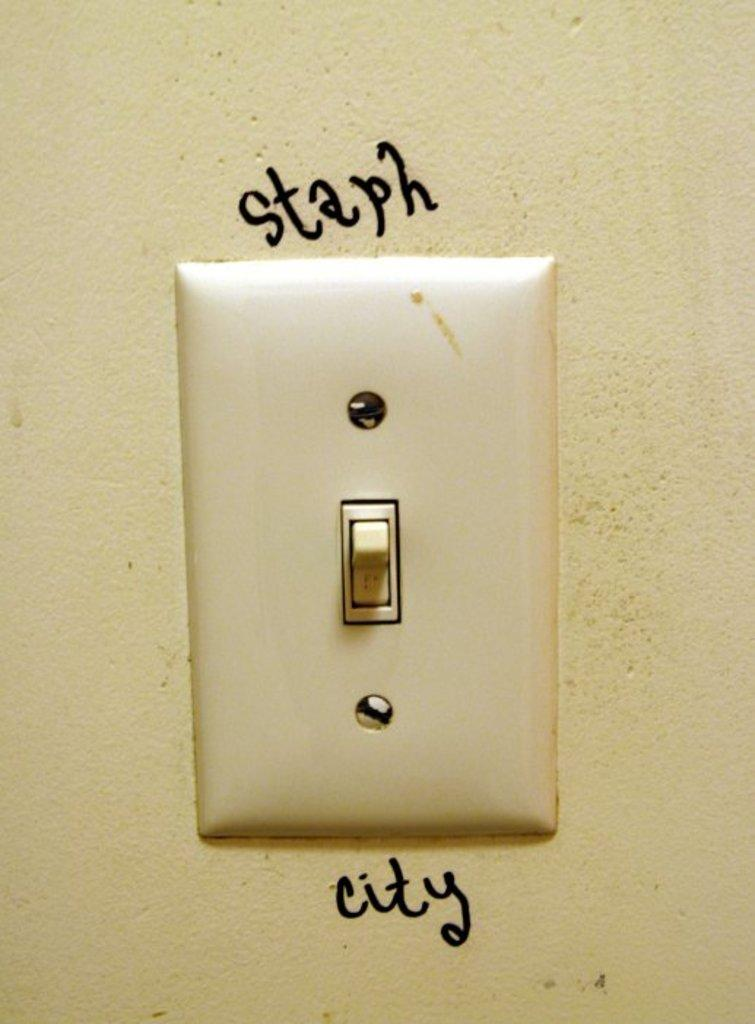<image>
Create a compact narrative representing the image presented. a light switch on a wall with the words staph city around it 